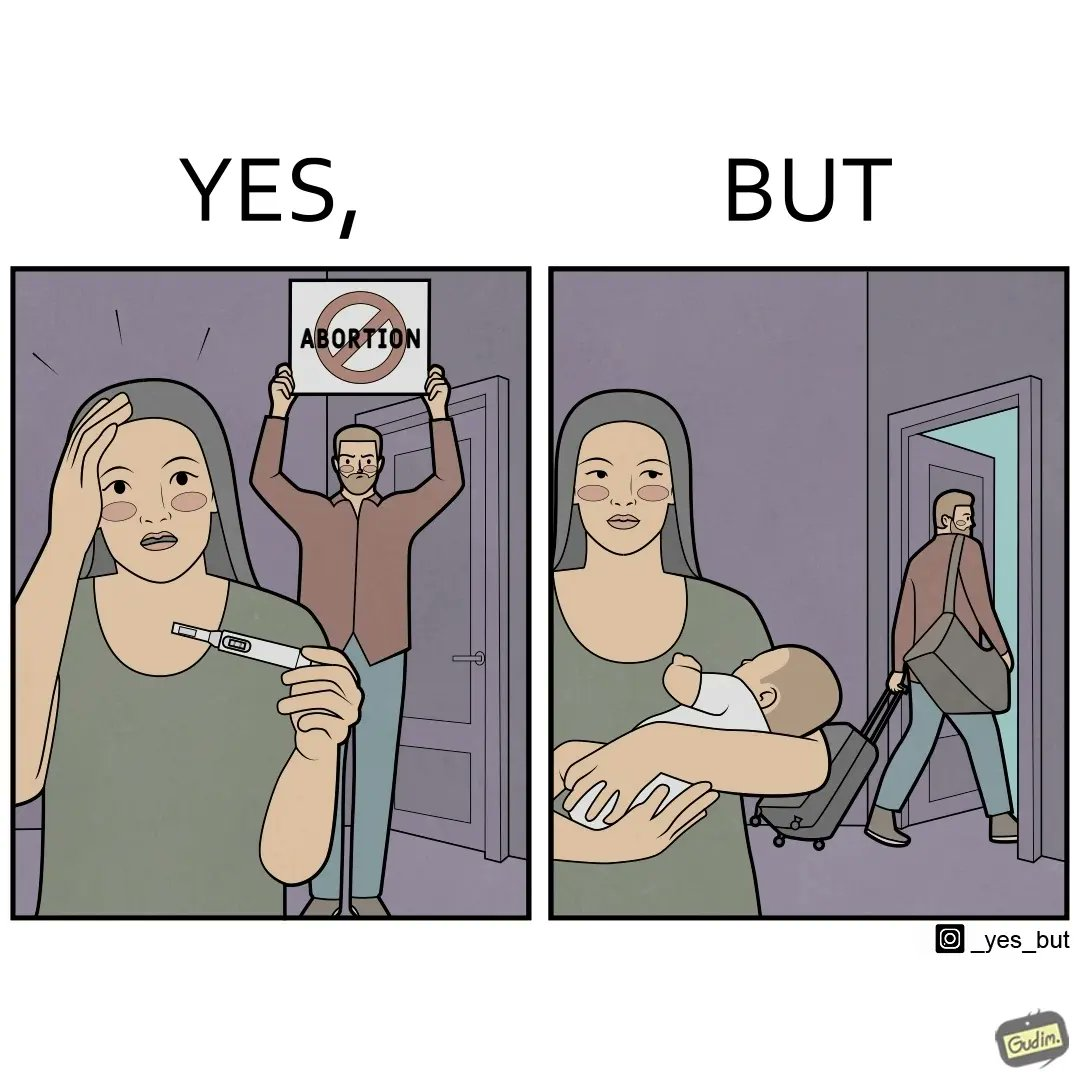Is this a satirical image? Yes, this image is satirical. 